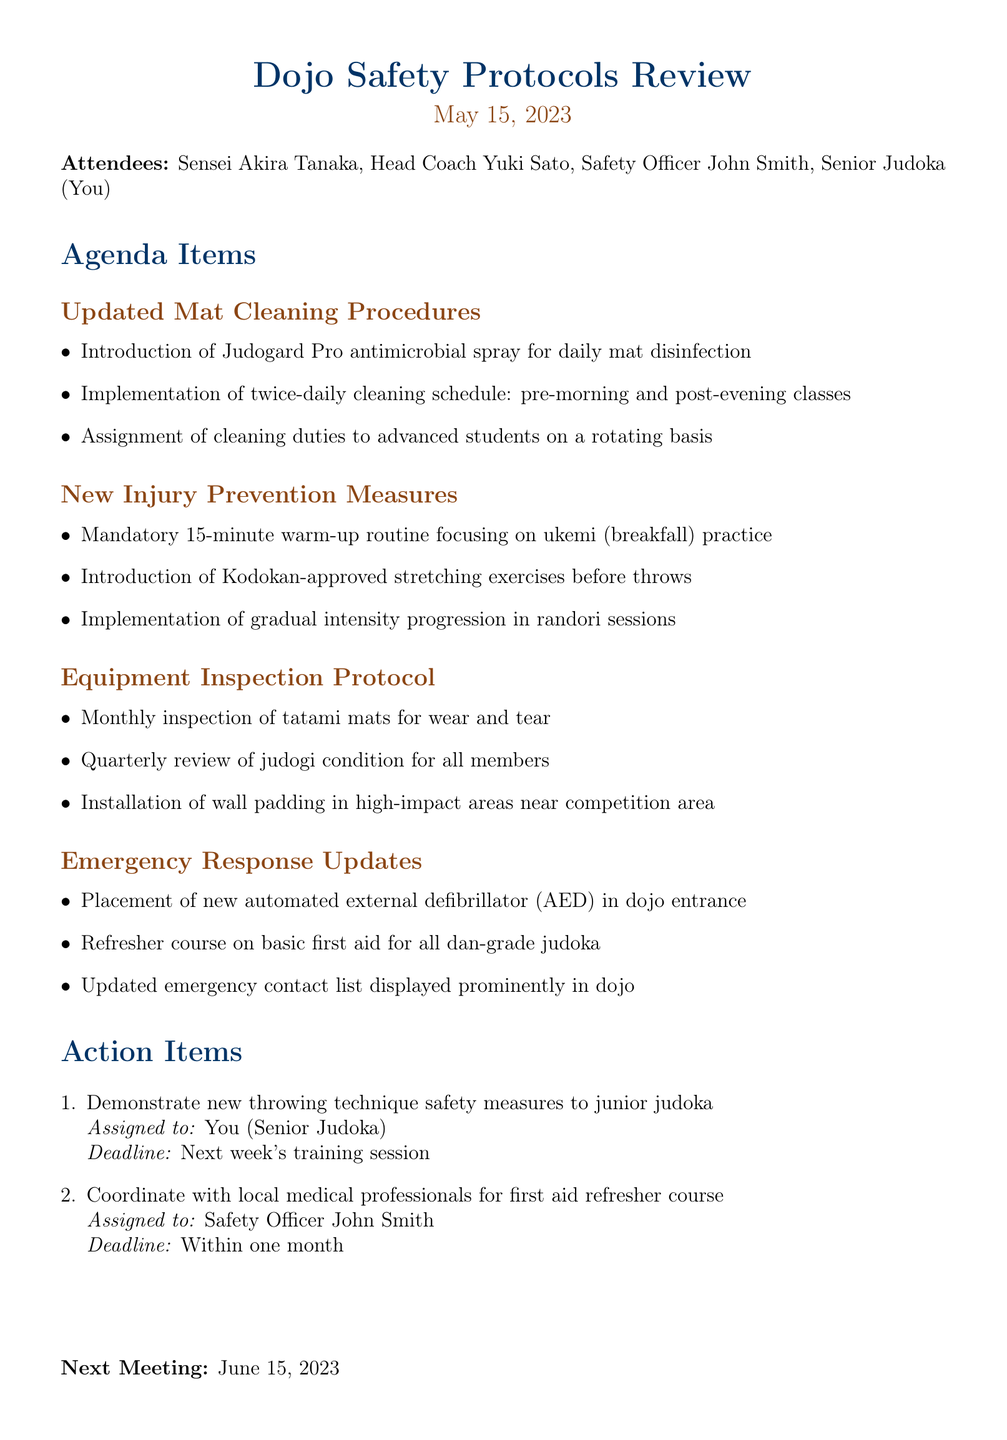what is the date of the meeting? The date of the meeting is clearly stated at the top of the document as May 15, 2023.
Answer: May 15, 2023 who is assigned to demonstrate new throwing technique safety measures? The action item specifies that you, the Senior Judoka, are assigned to demonstrate the new safety measures.
Answer: You (Senior Judoka) how many agenda items are listed? The document provides a clear list of agenda items, which includes four different sections.
Answer: Four what will be installed in high-impact areas near the competition area? The equipment inspection protocol mentions the installation of wall padding in those specific areas.
Answer: Wall padding when is the next meeting scheduled? The final section of the document indicates the date of the next meeting, which is June 15, 2023.
Answer: June 15, 2023 what is the main focus of the new injury prevention measures? The new injury prevention measures primarily emphasize a mandatory warm-up routine and stretching exercises before throws.
Answer: Warm-up routine and stretching exercises who will coordinate with local medical professionals for the first aid refresher course? The action items identify Safety Officer John Smith as the person responsible for coordinating this course.
Answer: Safety Officer John Smith what cleaning product is introduced for mat disinfection? The document specifically states the introduction of Judogard Pro antimicrobial spray for this purpose.
Answer: Judogard Pro 